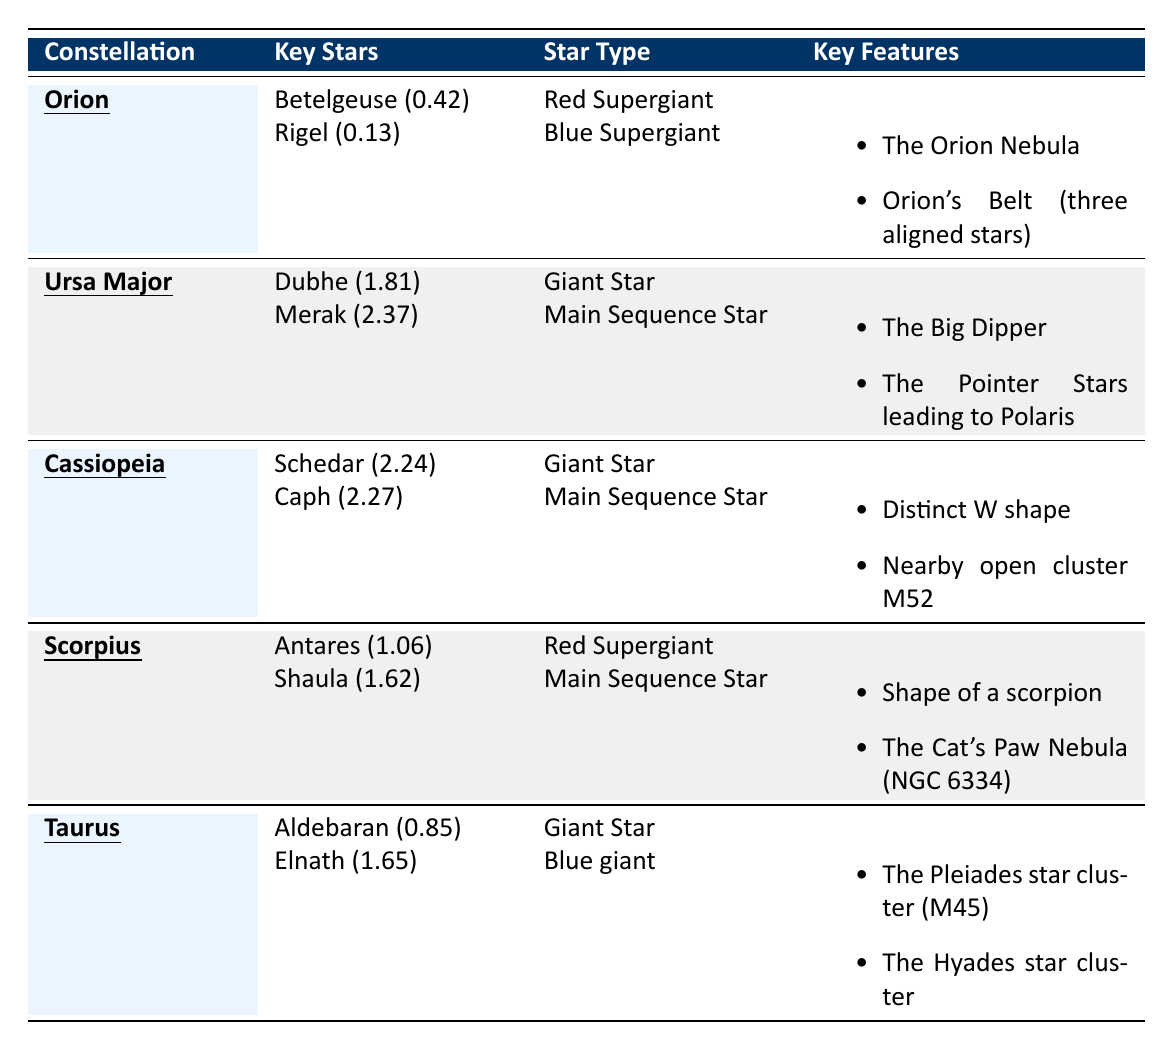What are the key stars in Orion? The table lists Betelgeuse and Rigel as the key stars in Orion.
Answer: Betelgeuse and Rigel Which constellation features a distinct W shape? The table indicates that Cassiopeia is characterized by a distinct W shape.
Answer: Cassiopeia What is the type of the brightest star in Taurus? The brightest star in Taurus is Aldebaran, which is classified as a Giant Star.
Answer: Giant Star Is Scorpius associated with a nebula? The table shows that Scorpius is linked with "The Cat’s Paw Nebula (NGC 6334)," so the statement is true.
Answer: Yes Which constellation's key features include "The Big Dipper"? According to the table, Ursa Major's key features include "The Big Dipper."
Answer: Ursa Major What is the average magnitude of the key stars in Cassiopeia? The magnitudes for the key stars in Cassiopeia are 2.24 and 2.27. The average is (2.24 + 2.27) / 2 = 2.255.
Answer: 2.255 Which constellation has key stars that include a Red Supergiant with a magnitude of 1.06? The table shows that Scorpius has Antares, a Red Supergiant, with a magnitude of 1.06.
Answer: Scorpius How does the brightness of Rigel compare to Aldebaran? Rigel has a magnitude of 0.13 and Aldebaran has a magnitude of 0.85. A lower magnitude means Rigel is brighter. Therefore, Rigel is brighter than Aldebaran.
Answer: Rigel is brighter What are the two key features of Taurus? According to the table, Taurus has two key features: "The Pleiades star cluster (M45)" and "The Hyades star cluster."
Answer: The Pleiades and The Hyades Which two constellations have Giant stars as key stars? The table indicates that Taurus and Cassiopeia both have key stars classified as Giant stars (Aldebaran and Schedar respectively).
Answer: Taurus and Cassiopeia What is the shape associated with the constellation Scorpius? The table mentions that Scorpius has a shape resembling a scorpion.
Answer: A scorpion 